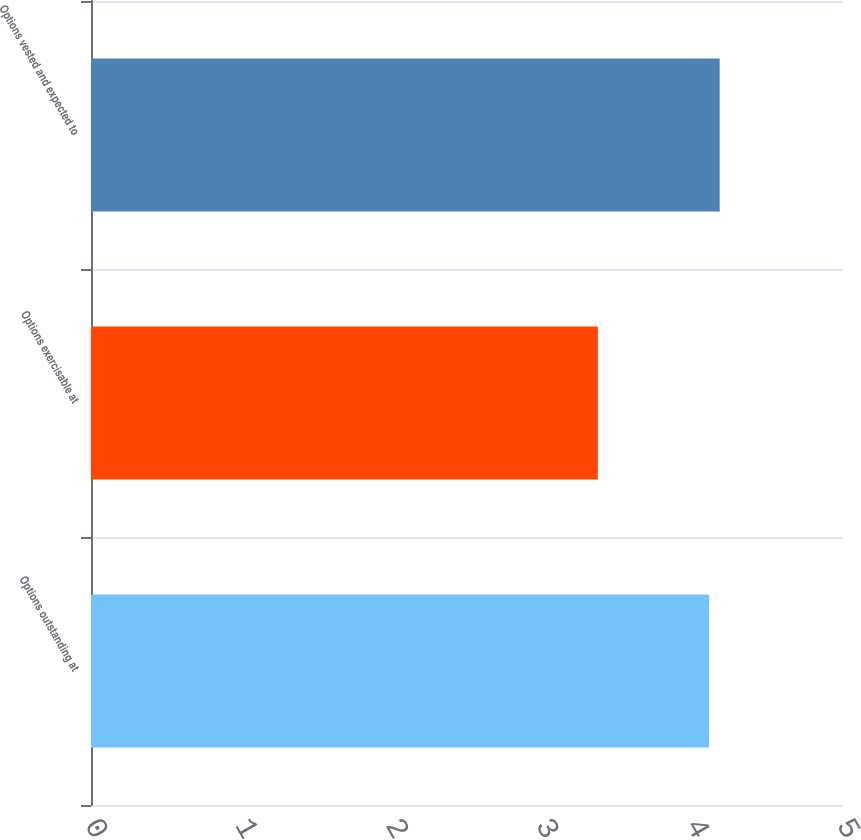Convert chart. <chart><loc_0><loc_0><loc_500><loc_500><bar_chart><fcel>Options outstanding at<fcel>Options exercisable at<fcel>Options vested and expected to<nl><fcel>4.11<fcel>3.37<fcel>4.18<nl></chart> 